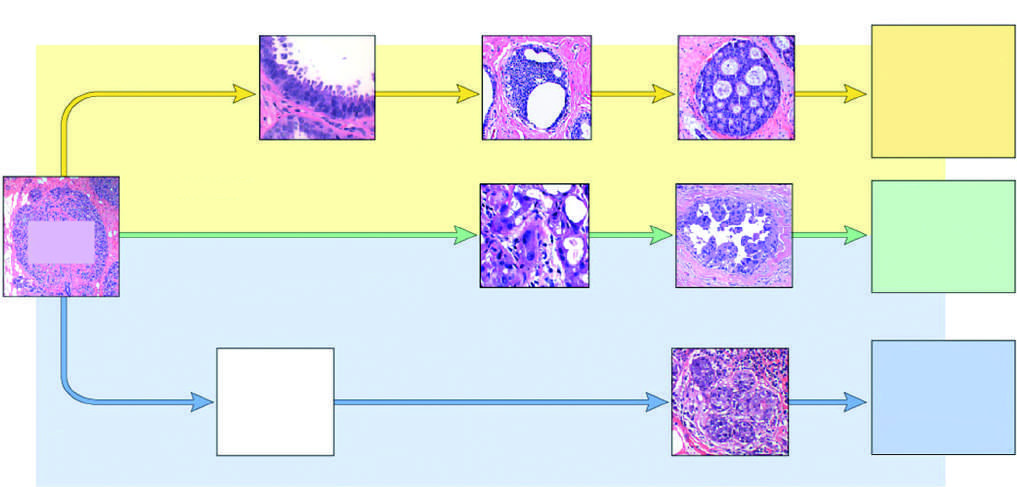re the majority of triple-negative cancers classified as basal-like by gene expression profiling?
Answer the question using a single word or phrase. Yes 